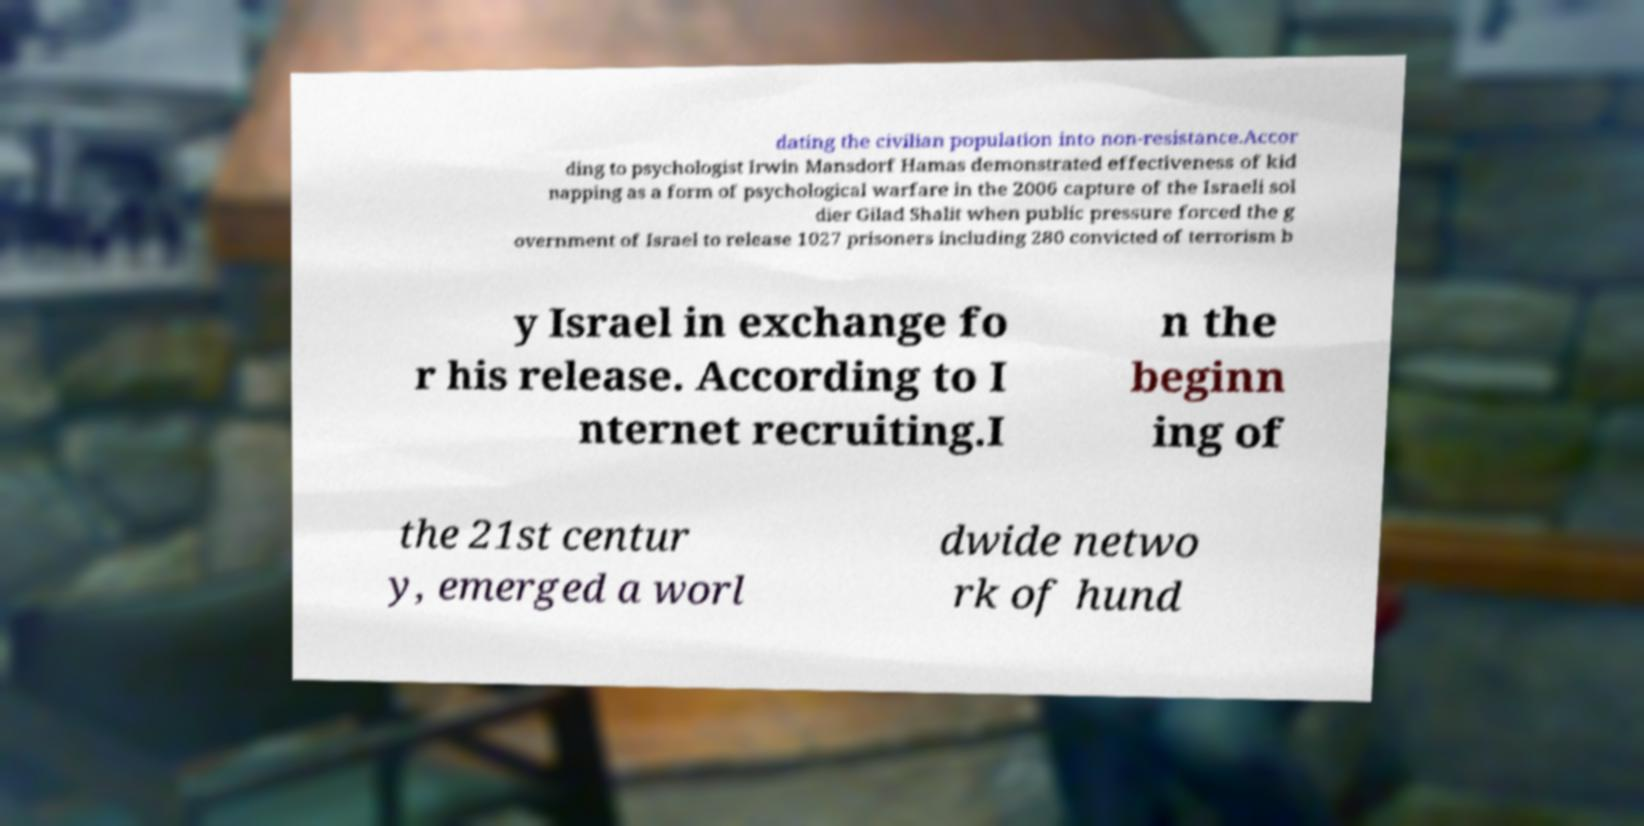Could you extract and type out the text from this image? dating the civilian population into non-resistance.Accor ding to psychologist Irwin Mansdorf Hamas demonstrated effectiveness of kid napping as a form of psychological warfare in the 2006 capture of the Israeli sol dier Gilad Shalit when public pressure forced the g overnment of Israel to release 1027 prisoners including 280 convicted of terrorism b y Israel in exchange fo r his release. According to I nternet recruiting.I n the beginn ing of the 21st centur y, emerged a worl dwide netwo rk of hund 